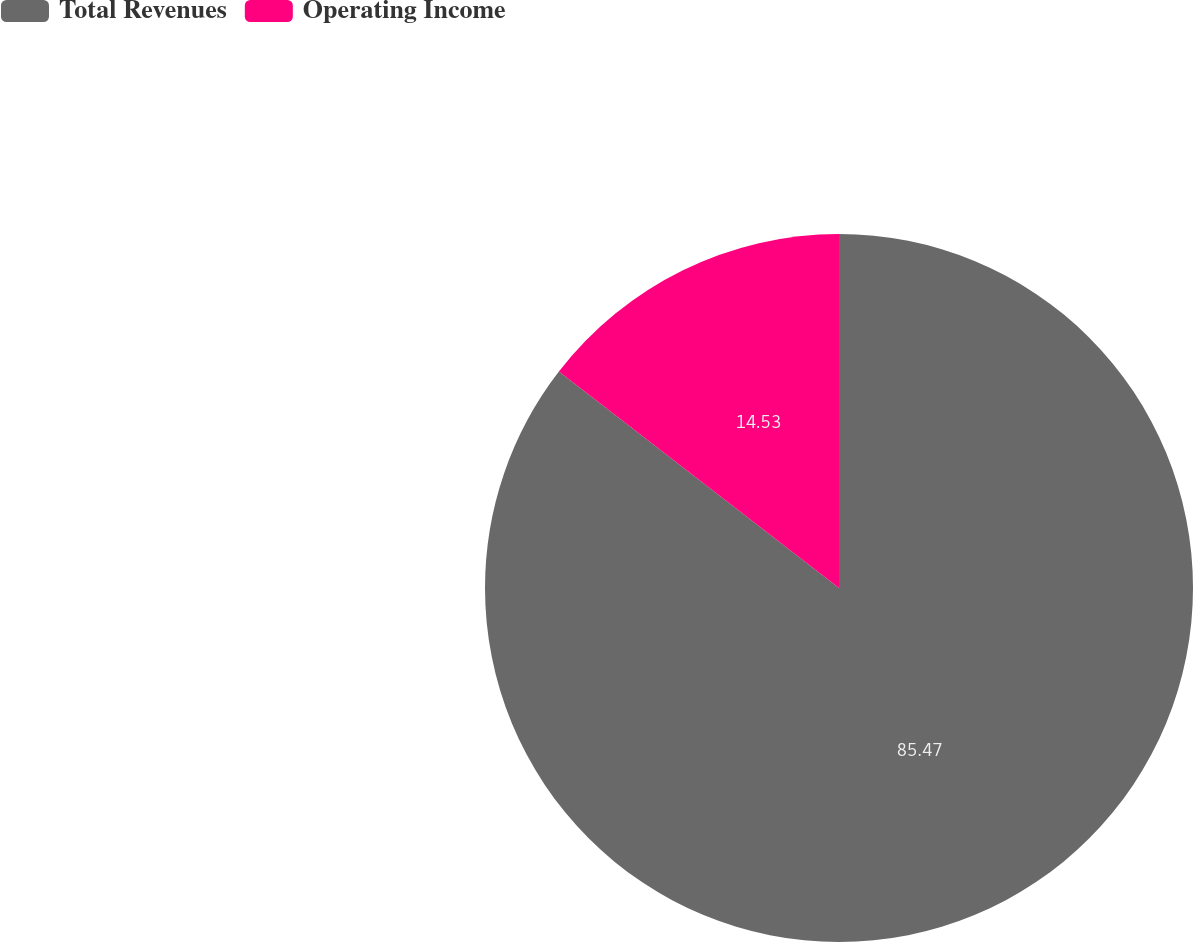Convert chart. <chart><loc_0><loc_0><loc_500><loc_500><pie_chart><fcel>Total Revenues<fcel>Operating Income<nl><fcel>85.47%<fcel>14.53%<nl></chart> 